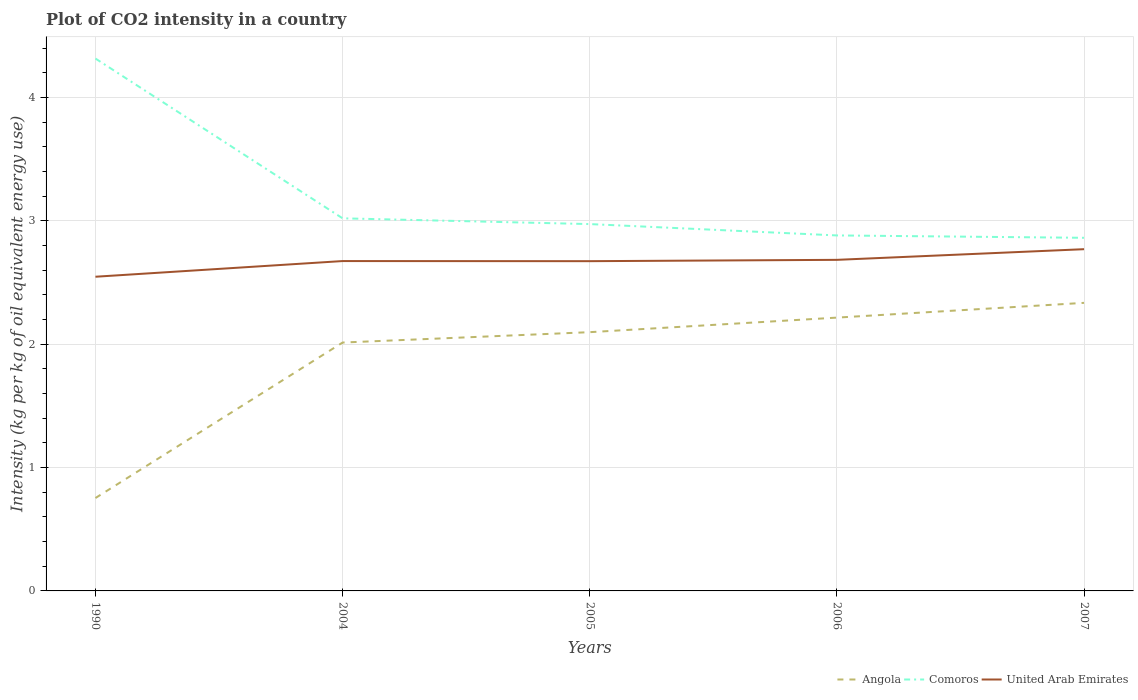Is the number of lines equal to the number of legend labels?
Provide a succinct answer. Yes. Across all years, what is the maximum CO2 intensity in in Angola?
Offer a terse response. 0.75. In which year was the CO2 intensity in in United Arab Emirates maximum?
Your answer should be compact. 1990. What is the total CO2 intensity in in Comoros in the graph?
Give a very brief answer. 0.11. What is the difference between the highest and the second highest CO2 intensity in in United Arab Emirates?
Ensure brevity in your answer.  0.22. How many lines are there?
Your response must be concise. 3. How many years are there in the graph?
Provide a short and direct response. 5. Does the graph contain any zero values?
Ensure brevity in your answer.  No. How many legend labels are there?
Provide a short and direct response. 3. How are the legend labels stacked?
Provide a succinct answer. Horizontal. What is the title of the graph?
Your response must be concise. Plot of CO2 intensity in a country. What is the label or title of the Y-axis?
Provide a succinct answer. Intensity (kg per kg of oil equivalent energy use). What is the Intensity (kg per kg of oil equivalent energy use) of Angola in 1990?
Offer a very short reply. 0.75. What is the Intensity (kg per kg of oil equivalent energy use) in Comoros in 1990?
Your response must be concise. 4.31. What is the Intensity (kg per kg of oil equivalent energy use) of United Arab Emirates in 1990?
Keep it short and to the point. 2.55. What is the Intensity (kg per kg of oil equivalent energy use) in Angola in 2004?
Your answer should be compact. 2.01. What is the Intensity (kg per kg of oil equivalent energy use) in Comoros in 2004?
Make the answer very short. 3.02. What is the Intensity (kg per kg of oil equivalent energy use) of United Arab Emirates in 2004?
Your response must be concise. 2.67. What is the Intensity (kg per kg of oil equivalent energy use) in Angola in 2005?
Make the answer very short. 2.1. What is the Intensity (kg per kg of oil equivalent energy use) in Comoros in 2005?
Make the answer very short. 2.97. What is the Intensity (kg per kg of oil equivalent energy use) of United Arab Emirates in 2005?
Your answer should be compact. 2.67. What is the Intensity (kg per kg of oil equivalent energy use) in Angola in 2006?
Provide a succinct answer. 2.22. What is the Intensity (kg per kg of oil equivalent energy use) in Comoros in 2006?
Your answer should be very brief. 2.88. What is the Intensity (kg per kg of oil equivalent energy use) in United Arab Emirates in 2006?
Offer a very short reply. 2.68. What is the Intensity (kg per kg of oil equivalent energy use) of Angola in 2007?
Make the answer very short. 2.33. What is the Intensity (kg per kg of oil equivalent energy use) in Comoros in 2007?
Provide a succinct answer. 2.86. What is the Intensity (kg per kg of oil equivalent energy use) of United Arab Emirates in 2007?
Provide a short and direct response. 2.77. Across all years, what is the maximum Intensity (kg per kg of oil equivalent energy use) in Angola?
Provide a succinct answer. 2.33. Across all years, what is the maximum Intensity (kg per kg of oil equivalent energy use) of Comoros?
Provide a succinct answer. 4.31. Across all years, what is the maximum Intensity (kg per kg of oil equivalent energy use) in United Arab Emirates?
Offer a very short reply. 2.77. Across all years, what is the minimum Intensity (kg per kg of oil equivalent energy use) of Angola?
Your answer should be compact. 0.75. Across all years, what is the minimum Intensity (kg per kg of oil equivalent energy use) in Comoros?
Offer a terse response. 2.86. Across all years, what is the minimum Intensity (kg per kg of oil equivalent energy use) of United Arab Emirates?
Ensure brevity in your answer.  2.55. What is the total Intensity (kg per kg of oil equivalent energy use) in Angola in the graph?
Provide a short and direct response. 9.41. What is the total Intensity (kg per kg of oil equivalent energy use) in Comoros in the graph?
Your response must be concise. 16.05. What is the total Intensity (kg per kg of oil equivalent energy use) of United Arab Emirates in the graph?
Keep it short and to the point. 13.35. What is the difference between the Intensity (kg per kg of oil equivalent energy use) of Angola in 1990 and that in 2004?
Offer a terse response. -1.26. What is the difference between the Intensity (kg per kg of oil equivalent energy use) of Comoros in 1990 and that in 2004?
Your answer should be very brief. 1.29. What is the difference between the Intensity (kg per kg of oil equivalent energy use) of United Arab Emirates in 1990 and that in 2004?
Keep it short and to the point. -0.13. What is the difference between the Intensity (kg per kg of oil equivalent energy use) in Angola in 1990 and that in 2005?
Give a very brief answer. -1.34. What is the difference between the Intensity (kg per kg of oil equivalent energy use) in Comoros in 1990 and that in 2005?
Ensure brevity in your answer.  1.34. What is the difference between the Intensity (kg per kg of oil equivalent energy use) of United Arab Emirates in 1990 and that in 2005?
Your answer should be compact. -0.13. What is the difference between the Intensity (kg per kg of oil equivalent energy use) of Angola in 1990 and that in 2006?
Provide a succinct answer. -1.46. What is the difference between the Intensity (kg per kg of oil equivalent energy use) of Comoros in 1990 and that in 2006?
Offer a very short reply. 1.43. What is the difference between the Intensity (kg per kg of oil equivalent energy use) in United Arab Emirates in 1990 and that in 2006?
Your answer should be compact. -0.14. What is the difference between the Intensity (kg per kg of oil equivalent energy use) of Angola in 1990 and that in 2007?
Your answer should be compact. -1.58. What is the difference between the Intensity (kg per kg of oil equivalent energy use) in Comoros in 1990 and that in 2007?
Your response must be concise. 1.45. What is the difference between the Intensity (kg per kg of oil equivalent energy use) of United Arab Emirates in 1990 and that in 2007?
Ensure brevity in your answer.  -0.22. What is the difference between the Intensity (kg per kg of oil equivalent energy use) of Angola in 2004 and that in 2005?
Make the answer very short. -0.08. What is the difference between the Intensity (kg per kg of oil equivalent energy use) in Comoros in 2004 and that in 2005?
Provide a short and direct response. 0.05. What is the difference between the Intensity (kg per kg of oil equivalent energy use) of United Arab Emirates in 2004 and that in 2005?
Your response must be concise. 0. What is the difference between the Intensity (kg per kg of oil equivalent energy use) of Angola in 2004 and that in 2006?
Provide a succinct answer. -0.2. What is the difference between the Intensity (kg per kg of oil equivalent energy use) of Comoros in 2004 and that in 2006?
Make the answer very short. 0.14. What is the difference between the Intensity (kg per kg of oil equivalent energy use) of United Arab Emirates in 2004 and that in 2006?
Ensure brevity in your answer.  -0.01. What is the difference between the Intensity (kg per kg of oil equivalent energy use) of Angola in 2004 and that in 2007?
Give a very brief answer. -0.32. What is the difference between the Intensity (kg per kg of oil equivalent energy use) of Comoros in 2004 and that in 2007?
Provide a succinct answer. 0.16. What is the difference between the Intensity (kg per kg of oil equivalent energy use) of United Arab Emirates in 2004 and that in 2007?
Your answer should be very brief. -0.1. What is the difference between the Intensity (kg per kg of oil equivalent energy use) in Angola in 2005 and that in 2006?
Ensure brevity in your answer.  -0.12. What is the difference between the Intensity (kg per kg of oil equivalent energy use) of Comoros in 2005 and that in 2006?
Your answer should be compact. 0.09. What is the difference between the Intensity (kg per kg of oil equivalent energy use) in United Arab Emirates in 2005 and that in 2006?
Your answer should be compact. -0.01. What is the difference between the Intensity (kg per kg of oil equivalent energy use) of Angola in 2005 and that in 2007?
Offer a terse response. -0.24. What is the difference between the Intensity (kg per kg of oil equivalent energy use) in Comoros in 2005 and that in 2007?
Ensure brevity in your answer.  0.11. What is the difference between the Intensity (kg per kg of oil equivalent energy use) in United Arab Emirates in 2005 and that in 2007?
Offer a very short reply. -0.1. What is the difference between the Intensity (kg per kg of oil equivalent energy use) in Angola in 2006 and that in 2007?
Your answer should be compact. -0.12. What is the difference between the Intensity (kg per kg of oil equivalent energy use) in Comoros in 2006 and that in 2007?
Offer a very short reply. 0.02. What is the difference between the Intensity (kg per kg of oil equivalent energy use) of United Arab Emirates in 2006 and that in 2007?
Make the answer very short. -0.09. What is the difference between the Intensity (kg per kg of oil equivalent energy use) of Angola in 1990 and the Intensity (kg per kg of oil equivalent energy use) of Comoros in 2004?
Offer a very short reply. -2.27. What is the difference between the Intensity (kg per kg of oil equivalent energy use) in Angola in 1990 and the Intensity (kg per kg of oil equivalent energy use) in United Arab Emirates in 2004?
Ensure brevity in your answer.  -1.92. What is the difference between the Intensity (kg per kg of oil equivalent energy use) in Comoros in 1990 and the Intensity (kg per kg of oil equivalent energy use) in United Arab Emirates in 2004?
Offer a terse response. 1.64. What is the difference between the Intensity (kg per kg of oil equivalent energy use) of Angola in 1990 and the Intensity (kg per kg of oil equivalent energy use) of Comoros in 2005?
Your answer should be very brief. -2.22. What is the difference between the Intensity (kg per kg of oil equivalent energy use) of Angola in 1990 and the Intensity (kg per kg of oil equivalent energy use) of United Arab Emirates in 2005?
Keep it short and to the point. -1.92. What is the difference between the Intensity (kg per kg of oil equivalent energy use) in Comoros in 1990 and the Intensity (kg per kg of oil equivalent energy use) in United Arab Emirates in 2005?
Ensure brevity in your answer.  1.64. What is the difference between the Intensity (kg per kg of oil equivalent energy use) of Angola in 1990 and the Intensity (kg per kg of oil equivalent energy use) of Comoros in 2006?
Provide a succinct answer. -2.13. What is the difference between the Intensity (kg per kg of oil equivalent energy use) in Angola in 1990 and the Intensity (kg per kg of oil equivalent energy use) in United Arab Emirates in 2006?
Your response must be concise. -1.93. What is the difference between the Intensity (kg per kg of oil equivalent energy use) of Comoros in 1990 and the Intensity (kg per kg of oil equivalent energy use) of United Arab Emirates in 2006?
Ensure brevity in your answer.  1.63. What is the difference between the Intensity (kg per kg of oil equivalent energy use) of Angola in 1990 and the Intensity (kg per kg of oil equivalent energy use) of Comoros in 2007?
Your answer should be compact. -2.11. What is the difference between the Intensity (kg per kg of oil equivalent energy use) of Angola in 1990 and the Intensity (kg per kg of oil equivalent energy use) of United Arab Emirates in 2007?
Your response must be concise. -2.02. What is the difference between the Intensity (kg per kg of oil equivalent energy use) in Comoros in 1990 and the Intensity (kg per kg of oil equivalent energy use) in United Arab Emirates in 2007?
Your response must be concise. 1.55. What is the difference between the Intensity (kg per kg of oil equivalent energy use) of Angola in 2004 and the Intensity (kg per kg of oil equivalent energy use) of Comoros in 2005?
Your answer should be very brief. -0.96. What is the difference between the Intensity (kg per kg of oil equivalent energy use) in Angola in 2004 and the Intensity (kg per kg of oil equivalent energy use) in United Arab Emirates in 2005?
Your response must be concise. -0.66. What is the difference between the Intensity (kg per kg of oil equivalent energy use) of Comoros in 2004 and the Intensity (kg per kg of oil equivalent energy use) of United Arab Emirates in 2005?
Provide a short and direct response. 0.35. What is the difference between the Intensity (kg per kg of oil equivalent energy use) of Angola in 2004 and the Intensity (kg per kg of oil equivalent energy use) of Comoros in 2006?
Ensure brevity in your answer.  -0.87. What is the difference between the Intensity (kg per kg of oil equivalent energy use) in Angola in 2004 and the Intensity (kg per kg of oil equivalent energy use) in United Arab Emirates in 2006?
Give a very brief answer. -0.67. What is the difference between the Intensity (kg per kg of oil equivalent energy use) in Comoros in 2004 and the Intensity (kg per kg of oil equivalent energy use) in United Arab Emirates in 2006?
Provide a short and direct response. 0.34. What is the difference between the Intensity (kg per kg of oil equivalent energy use) of Angola in 2004 and the Intensity (kg per kg of oil equivalent energy use) of Comoros in 2007?
Offer a terse response. -0.85. What is the difference between the Intensity (kg per kg of oil equivalent energy use) of Angola in 2004 and the Intensity (kg per kg of oil equivalent energy use) of United Arab Emirates in 2007?
Provide a short and direct response. -0.76. What is the difference between the Intensity (kg per kg of oil equivalent energy use) of Comoros in 2004 and the Intensity (kg per kg of oil equivalent energy use) of United Arab Emirates in 2007?
Ensure brevity in your answer.  0.25. What is the difference between the Intensity (kg per kg of oil equivalent energy use) in Angola in 2005 and the Intensity (kg per kg of oil equivalent energy use) in Comoros in 2006?
Your response must be concise. -0.78. What is the difference between the Intensity (kg per kg of oil equivalent energy use) of Angola in 2005 and the Intensity (kg per kg of oil equivalent energy use) of United Arab Emirates in 2006?
Keep it short and to the point. -0.59. What is the difference between the Intensity (kg per kg of oil equivalent energy use) in Comoros in 2005 and the Intensity (kg per kg of oil equivalent energy use) in United Arab Emirates in 2006?
Ensure brevity in your answer.  0.29. What is the difference between the Intensity (kg per kg of oil equivalent energy use) in Angola in 2005 and the Intensity (kg per kg of oil equivalent energy use) in Comoros in 2007?
Keep it short and to the point. -0.76. What is the difference between the Intensity (kg per kg of oil equivalent energy use) in Angola in 2005 and the Intensity (kg per kg of oil equivalent energy use) in United Arab Emirates in 2007?
Provide a short and direct response. -0.67. What is the difference between the Intensity (kg per kg of oil equivalent energy use) in Comoros in 2005 and the Intensity (kg per kg of oil equivalent energy use) in United Arab Emirates in 2007?
Make the answer very short. 0.2. What is the difference between the Intensity (kg per kg of oil equivalent energy use) of Angola in 2006 and the Intensity (kg per kg of oil equivalent energy use) of Comoros in 2007?
Ensure brevity in your answer.  -0.65. What is the difference between the Intensity (kg per kg of oil equivalent energy use) in Angola in 2006 and the Intensity (kg per kg of oil equivalent energy use) in United Arab Emirates in 2007?
Give a very brief answer. -0.55. What is the difference between the Intensity (kg per kg of oil equivalent energy use) in Comoros in 2006 and the Intensity (kg per kg of oil equivalent energy use) in United Arab Emirates in 2007?
Provide a succinct answer. 0.11. What is the average Intensity (kg per kg of oil equivalent energy use) in Angola per year?
Offer a very short reply. 1.88. What is the average Intensity (kg per kg of oil equivalent energy use) of Comoros per year?
Your response must be concise. 3.21. What is the average Intensity (kg per kg of oil equivalent energy use) of United Arab Emirates per year?
Offer a terse response. 2.67. In the year 1990, what is the difference between the Intensity (kg per kg of oil equivalent energy use) of Angola and Intensity (kg per kg of oil equivalent energy use) of Comoros?
Provide a short and direct response. -3.56. In the year 1990, what is the difference between the Intensity (kg per kg of oil equivalent energy use) of Angola and Intensity (kg per kg of oil equivalent energy use) of United Arab Emirates?
Offer a very short reply. -1.79. In the year 1990, what is the difference between the Intensity (kg per kg of oil equivalent energy use) of Comoros and Intensity (kg per kg of oil equivalent energy use) of United Arab Emirates?
Ensure brevity in your answer.  1.77. In the year 2004, what is the difference between the Intensity (kg per kg of oil equivalent energy use) of Angola and Intensity (kg per kg of oil equivalent energy use) of Comoros?
Your answer should be compact. -1.01. In the year 2004, what is the difference between the Intensity (kg per kg of oil equivalent energy use) of Angola and Intensity (kg per kg of oil equivalent energy use) of United Arab Emirates?
Give a very brief answer. -0.66. In the year 2004, what is the difference between the Intensity (kg per kg of oil equivalent energy use) of Comoros and Intensity (kg per kg of oil equivalent energy use) of United Arab Emirates?
Your answer should be compact. 0.35. In the year 2005, what is the difference between the Intensity (kg per kg of oil equivalent energy use) in Angola and Intensity (kg per kg of oil equivalent energy use) in Comoros?
Your answer should be very brief. -0.88. In the year 2005, what is the difference between the Intensity (kg per kg of oil equivalent energy use) of Angola and Intensity (kg per kg of oil equivalent energy use) of United Arab Emirates?
Keep it short and to the point. -0.58. In the year 2005, what is the difference between the Intensity (kg per kg of oil equivalent energy use) of Comoros and Intensity (kg per kg of oil equivalent energy use) of United Arab Emirates?
Offer a terse response. 0.3. In the year 2006, what is the difference between the Intensity (kg per kg of oil equivalent energy use) of Angola and Intensity (kg per kg of oil equivalent energy use) of Comoros?
Offer a very short reply. -0.67. In the year 2006, what is the difference between the Intensity (kg per kg of oil equivalent energy use) of Angola and Intensity (kg per kg of oil equivalent energy use) of United Arab Emirates?
Offer a terse response. -0.47. In the year 2006, what is the difference between the Intensity (kg per kg of oil equivalent energy use) in Comoros and Intensity (kg per kg of oil equivalent energy use) in United Arab Emirates?
Offer a very short reply. 0.2. In the year 2007, what is the difference between the Intensity (kg per kg of oil equivalent energy use) of Angola and Intensity (kg per kg of oil equivalent energy use) of Comoros?
Your response must be concise. -0.53. In the year 2007, what is the difference between the Intensity (kg per kg of oil equivalent energy use) in Angola and Intensity (kg per kg of oil equivalent energy use) in United Arab Emirates?
Make the answer very short. -0.43. In the year 2007, what is the difference between the Intensity (kg per kg of oil equivalent energy use) in Comoros and Intensity (kg per kg of oil equivalent energy use) in United Arab Emirates?
Your answer should be compact. 0.09. What is the ratio of the Intensity (kg per kg of oil equivalent energy use) of Angola in 1990 to that in 2004?
Make the answer very short. 0.37. What is the ratio of the Intensity (kg per kg of oil equivalent energy use) of Comoros in 1990 to that in 2004?
Make the answer very short. 1.43. What is the ratio of the Intensity (kg per kg of oil equivalent energy use) in United Arab Emirates in 1990 to that in 2004?
Provide a succinct answer. 0.95. What is the ratio of the Intensity (kg per kg of oil equivalent energy use) in Angola in 1990 to that in 2005?
Ensure brevity in your answer.  0.36. What is the ratio of the Intensity (kg per kg of oil equivalent energy use) in Comoros in 1990 to that in 2005?
Your response must be concise. 1.45. What is the ratio of the Intensity (kg per kg of oil equivalent energy use) in United Arab Emirates in 1990 to that in 2005?
Your answer should be compact. 0.95. What is the ratio of the Intensity (kg per kg of oil equivalent energy use) of Angola in 1990 to that in 2006?
Offer a very short reply. 0.34. What is the ratio of the Intensity (kg per kg of oil equivalent energy use) of Comoros in 1990 to that in 2006?
Your response must be concise. 1.5. What is the ratio of the Intensity (kg per kg of oil equivalent energy use) in United Arab Emirates in 1990 to that in 2006?
Your answer should be very brief. 0.95. What is the ratio of the Intensity (kg per kg of oil equivalent energy use) in Angola in 1990 to that in 2007?
Offer a very short reply. 0.32. What is the ratio of the Intensity (kg per kg of oil equivalent energy use) in Comoros in 1990 to that in 2007?
Provide a short and direct response. 1.51. What is the ratio of the Intensity (kg per kg of oil equivalent energy use) in United Arab Emirates in 1990 to that in 2007?
Ensure brevity in your answer.  0.92. What is the ratio of the Intensity (kg per kg of oil equivalent energy use) of Angola in 2004 to that in 2005?
Your answer should be compact. 0.96. What is the ratio of the Intensity (kg per kg of oil equivalent energy use) in Comoros in 2004 to that in 2005?
Keep it short and to the point. 1.02. What is the ratio of the Intensity (kg per kg of oil equivalent energy use) in Angola in 2004 to that in 2006?
Make the answer very short. 0.91. What is the ratio of the Intensity (kg per kg of oil equivalent energy use) of Comoros in 2004 to that in 2006?
Keep it short and to the point. 1.05. What is the ratio of the Intensity (kg per kg of oil equivalent energy use) of Angola in 2004 to that in 2007?
Provide a succinct answer. 0.86. What is the ratio of the Intensity (kg per kg of oil equivalent energy use) of Comoros in 2004 to that in 2007?
Ensure brevity in your answer.  1.06. What is the ratio of the Intensity (kg per kg of oil equivalent energy use) in United Arab Emirates in 2004 to that in 2007?
Provide a succinct answer. 0.97. What is the ratio of the Intensity (kg per kg of oil equivalent energy use) in Angola in 2005 to that in 2006?
Provide a short and direct response. 0.95. What is the ratio of the Intensity (kg per kg of oil equivalent energy use) in Comoros in 2005 to that in 2006?
Offer a very short reply. 1.03. What is the ratio of the Intensity (kg per kg of oil equivalent energy use) in Angola in 2005 to that in 2007?
Provide a succinct answer. 0.9. What is the ratio of the Intensity (kg per kg of oil equivalent energy use) of Comoros in 2005 to that in 2007?
Give a very brief answer. 1.04. What is the ratio of the Intensity (kg per kg of oil equivalent energy use) in United Arab Emirates in 2005 to that in 2007?
Keep it short and to the point. 0.96. What is the ratio of the Intensity (kg per kg of oil equivalent energy use) of Angola in 2006 to that in 2007?
Your answer should be very brief. 0.95. What is the ratio of the Intensity (kg per kg of oil equivalent energy use) in United Arab Emirates in 2006 to that in 2007?
Your answer should be compact. 0.97. What is the difference between the highest and the second highest Intensity (kg per kg of oil equivalent energy use) in Angola?
Make the answer very short. 0.12. What is the difference between the highest and the second highest Intensity (kg per kg of oil equivalent energy use) of Comoros?
Your response must be concise. 1.29. What is the difference between the highest and the second highest Intensity (kg per kg of oil equivalent energy use) in United Arab Emirates?
Offer a terse response. 0.09. What is the difference between the highest and the lowest Intensity (kg per kg of oil equivalent energy use) of Angola?
Ensure brevity in your answer.  1.58. What is the difference between the highest and the lowest Intensity (kg per kg of oil equivalent energy use) in Comoros?
Keep it short and to the point. 1.45. What is the difference between the highest and the lowest Intensity (kg per kg of oil equivalent energy use) of United Arab Emirates?
Provide a succinct answer. 0.22. 